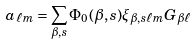<formula> <loc_0><loc_0><loc_500><loc_500>a _ { \ell m } = \sum _ { \beta , s } \Phi _ { 0 } ( \beta , s ) \xi _ { \beta , s \ell m } G _ { \beta \ell }</formula> 